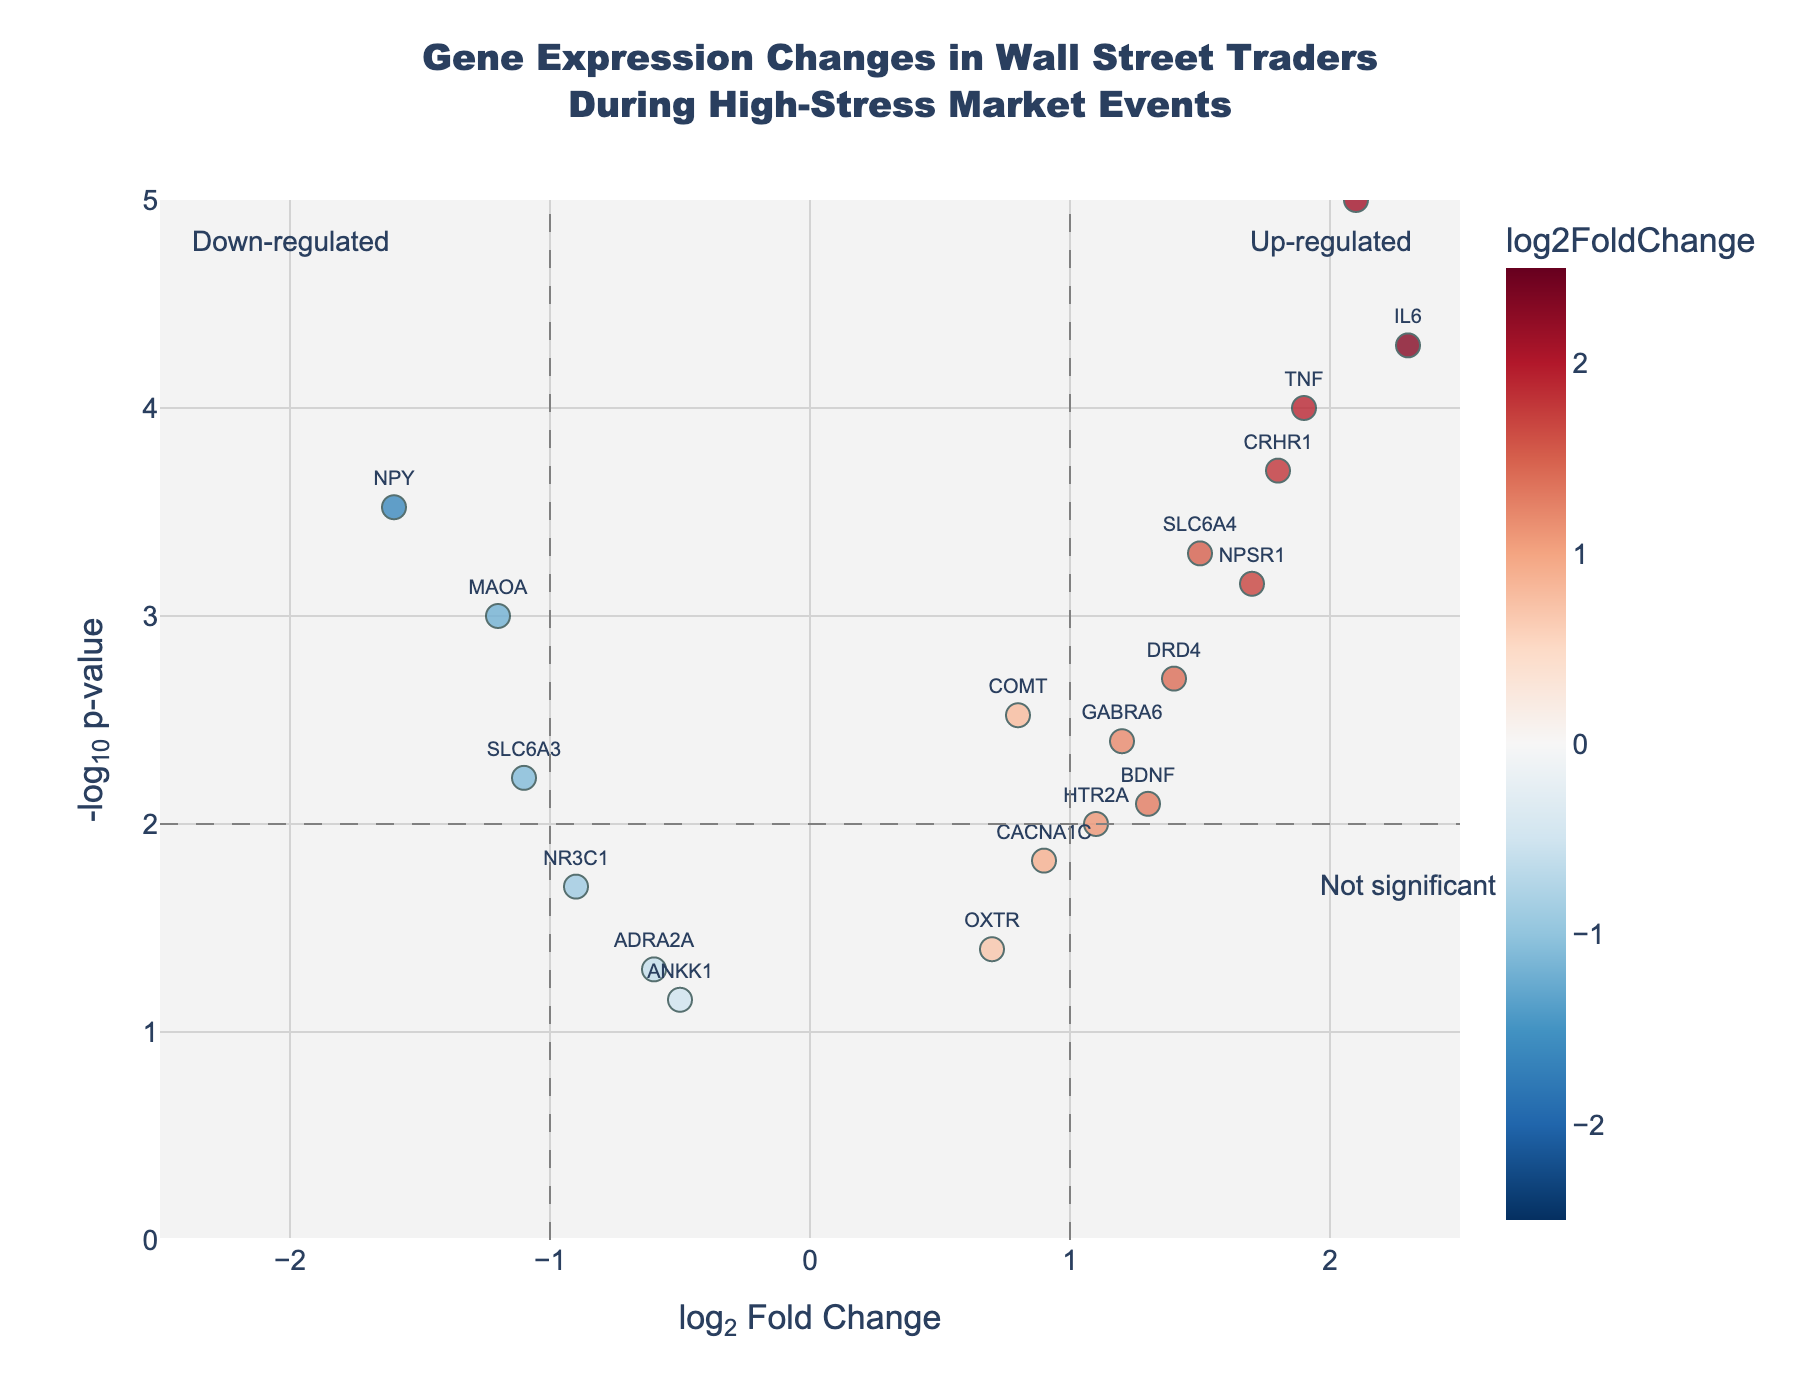How many genes are shown in the volcano plot? To determine the number of genes, count the number of data points plotted. Each point represents a gene.
Answer: 20 Which gene has the highest log2 fold change value? Look for the dot farthest to the right on the x-axis. Hover over or refer to the labels to identify the gene.
Answer: CRP Which gene has the lowest p-value? Find the point with the highest value on the y-axis, as -log10(p-value) higher values correspond to lower p-values.
Answer: FKBP5 Are there more genes up-regulated or down-regulated according to the plot? Up-regulated genes have positive log2 fold changes (right side), and down-regulated genes have negative log2 fold changes (left side). Count the points on each side.
Answer: Up-regulated How many genes have a log2 fold change greater than 1? Identify and count the points to the right of the vertical line at log2 fold change = 1.
Answer: 7 Which gene is labeled as the most statistically significant up-regulated gene? Look for the point farthest up and to the right (highest on y-axis and positive on x-axis).
Answer: CRP What is the range of the y-axis (in -log10(p-value)) in the plot? Observe the y-axis markings from the bottom to the top.
Answer: 0 to 5 How does the log2 fold change of NPY compare to IL6? Check the position of both genes along the x-axis. NPY is to the left (negative side), and IL6 is to the right (positive side).
Answer: NPY < IL6 How many genes are down-regulated with a p-value less than 0.01? Count points left of log2 fold change = 0 and above the line for -log10(p-value) = 2.
Answer: 3 Which gene with a log2 fold change of greater than 1 has the smallest p-value? Look for the points to the right of log2 fold change = 1 and identify the one highest on the y-axis.
Answer: CRP 